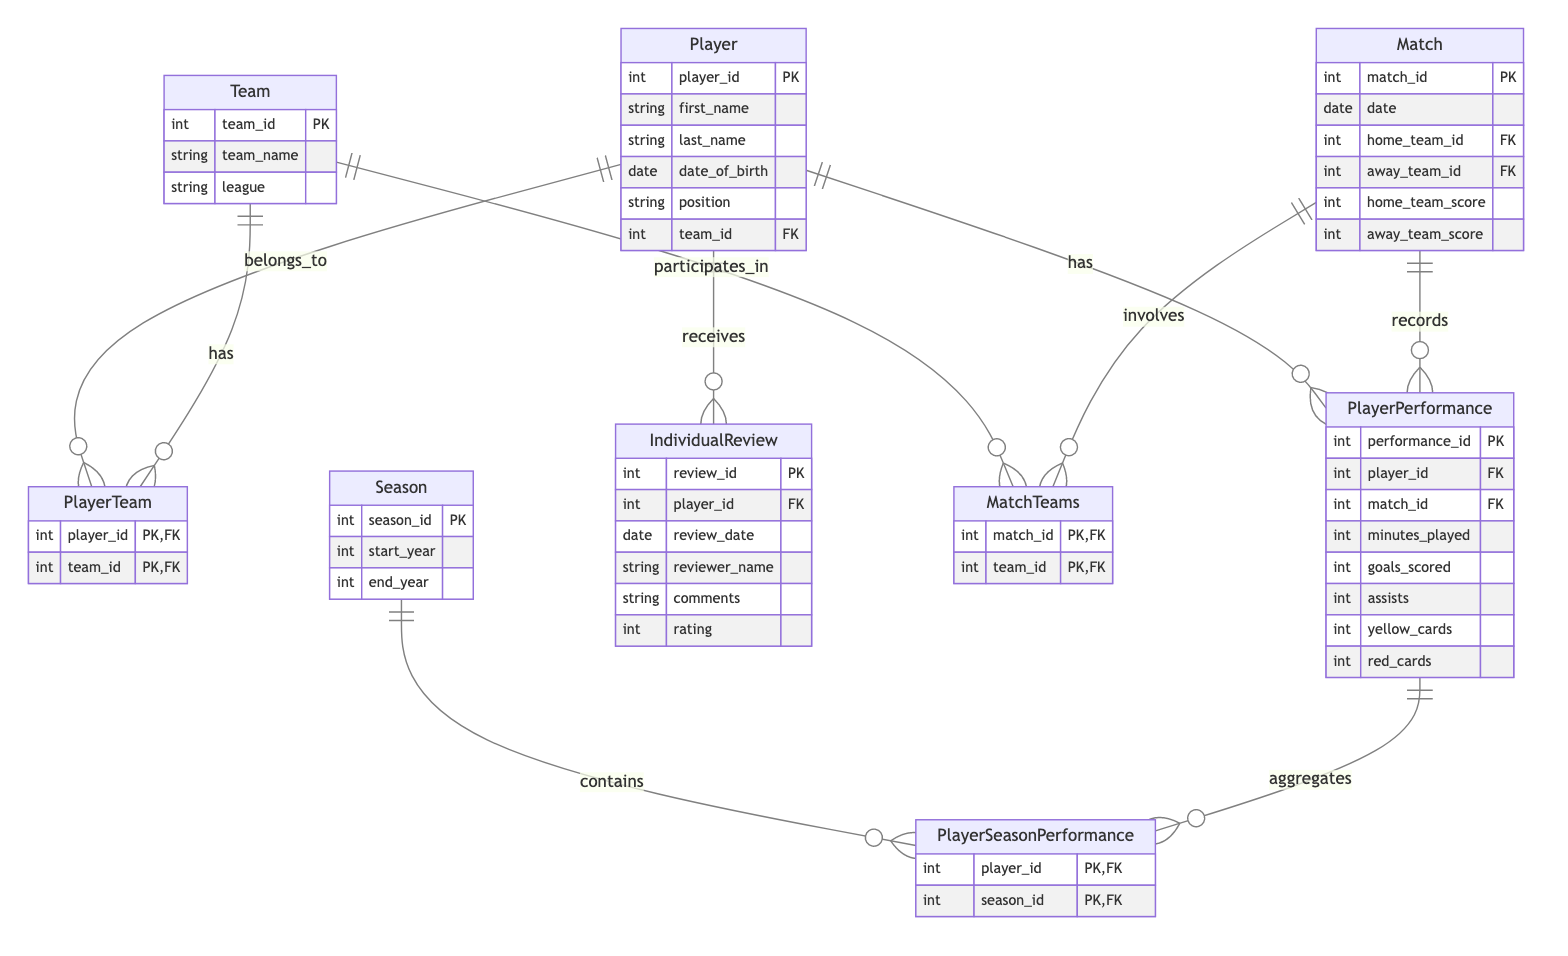What is the primary key of the Player entity? The primary key of the Player entity is player_id, which uniquely identifies each player in the database.
Answer: player_id How many attributes does the Team entity have? The Team entity has three attributes: team_id, team_name, and league.
Answer: three What relationship connects the Player and Team entities? The Player and Team entities are connected by the PlayerTeam relationship, which represents the association between players and their teams.
Answer: PlayerTeam Which entity records individual performance statistics during matches? The PlayerPerformance entity records individual performance statistics during matches, such as goals scored and minutes played.
Answer: PlayerPerformance What does the Match entity track in terms of game outcomes? The Match entity tracks the home_team_score and away_team_score to represent the outcomes of the games.
Answer: home_team_score and away_team_score What is the purpose of the IndividualReview entity? The IndividualReview entity is used to evaluate players, documenting reviews including comments and ratings given by reviewers.
Answer: evaluate players How many matches can a PlayerPerformance be associated with? A PlayerPerformance can be associated with one match, as each record specifically relates to performance in that match.
Answer: one What is the highest level of abstraction at which seasons are organized in the diagram? Seasons are organized at the highest level within the Season entity, which tracks the time frame of each season through start and end years.
Answer: Season How is a player's performance across different seasons aggregated in the diagram? A player's performance across different seasons is aggregated through the PlayerSeasonPerformance relationship, which connects PlayerPerformance to the Season entity.
Answer: PlayerSeasonPerformance 